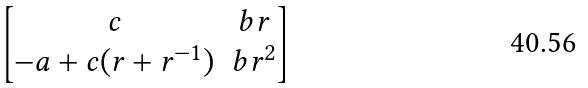Convert formula to latex. <formula><loc_0><loc_0><loc_500><loc_500>\begin{bmatrix} c & b r \\ - a + c ( r + r ^ { - 1 } ) & b r ^ { 2 } \end{bmatrix}</formula> 